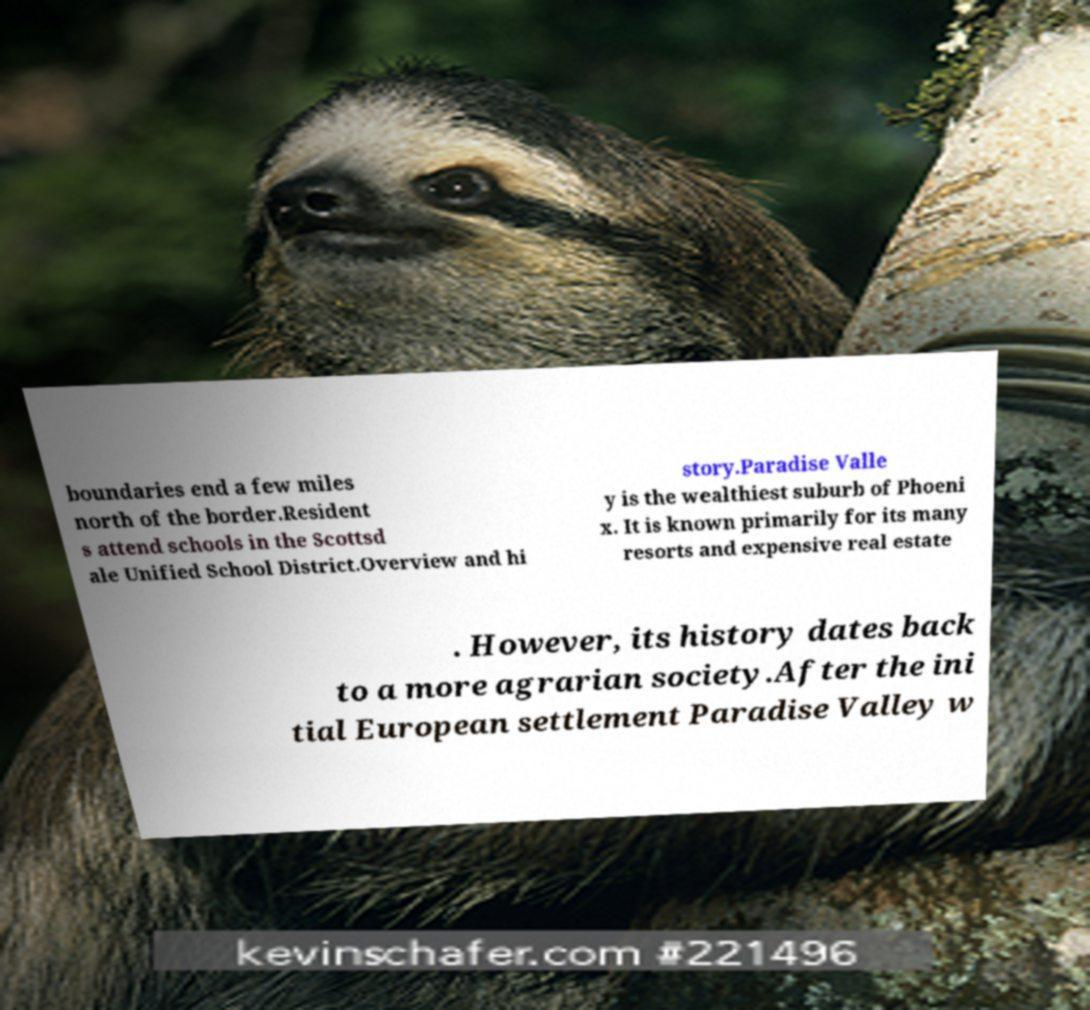Please read and relay the text visible in this image. What does it say? boundaries end a few miles north of the border.Resident s attend schools in the Scottsd ale Unified School District.Overview and hi story.Paradise Valle y is the wealthiest suburb of Phoeni x. It is known primarily for its many resorts and expensive real estate . However, its history dates back to a more agrarian society.After the ini tial European settlement Paradise Valley w 